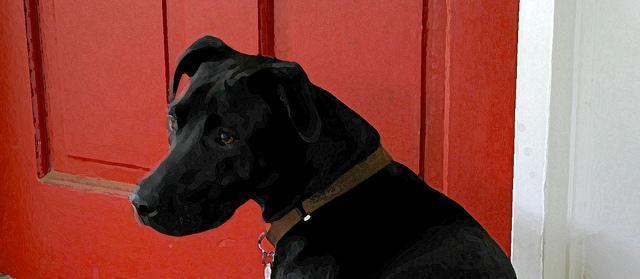How many skateboards are there?
Give a very brief answer. 0. 